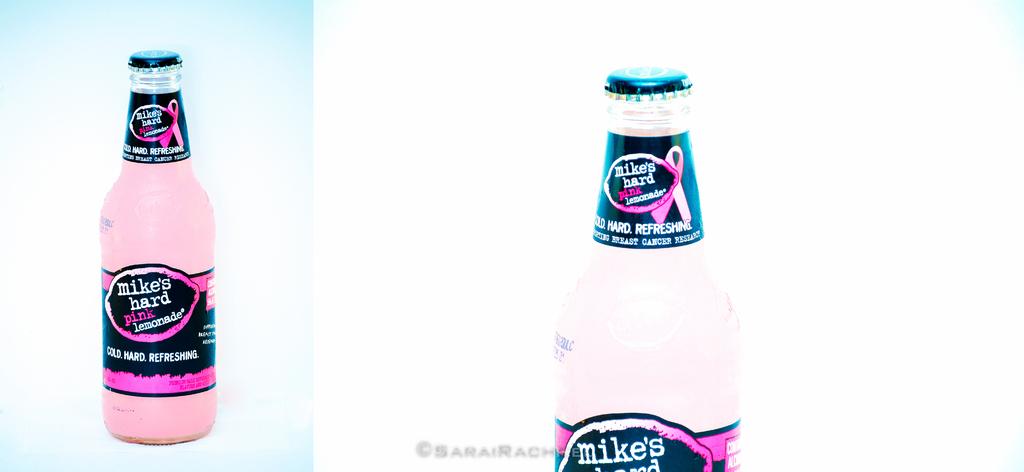What brand of alcohol?
Ensure brevity in your answer.  Mikes. Who's hard lemonade is this?
Keep it short and to the point. Mike's. 